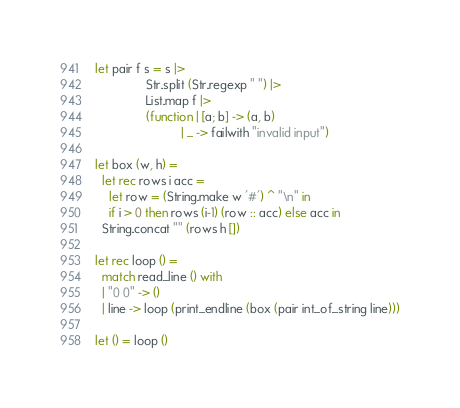<code> <loc_0><loc_0><loc_500><loc_500><_OCaml_>let pair f s = s |>
               Str.split (Str.regexp " ") |>
               List.map f |>
               (function | [a; b] -> (a, b)
                         | _ -> failwith "invalid input")

let box (w, h) =
  let rec rows i acc =
    let row = (String.make w '#') ^ "\n" in
    if i > 0 then rows (i-1) (row :: acc) else acc in
  String.concat "" (rows h [])

let rec loop () =
  match read_line () with
  | "0 0" -> ()
  | line -> loop (print_endline (box (pair int_of_string line)))

let () = loop ()</code> 